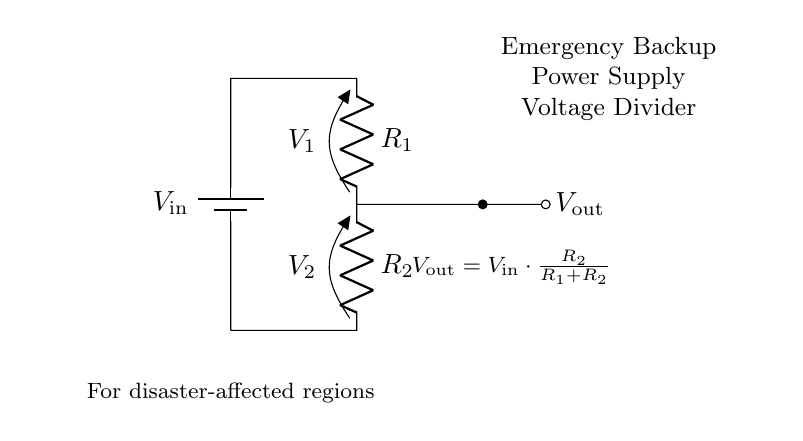What is the input voltage in the circuit? The input voltage is represented as V_in, which is the potential supplied by the battery.
Answer: V_in What does V_out represent? V_out is the output voltage across resistor R2, computed using the voltage divider formula.
Answer: V_out What is the relationship between R1 and R2? R1 and R2 are resistors in series, and their values influence the output voltage V_out. They are connected one after the other in the circuit.
Answer: R1 and R2 are in series What is the formula for V_out? The formula given in the diagram states that V_out is equal to V_in multiplied by the ratio of R2 to the total resistance (R1 + R2).
Answer: V_out = V_in * (R2 / (R1 + R2)) If R1 is larger than R2, what happens to V_out? If R1 is larger than R2, according to the voltage divider principle, V_out will be smaller, as more voltage is dropped across R1.
Answer: V_out decreases How does this circuit help in disaster-affected regions? The voltage divider circuit assists by providing a specific lower voltage output for powering devices that require less voltage than the input, useful for efficient power distribution in emergencies.
Answer: Provides lower voltage output What type of circuit is represented here? This circuit is a Voltage Divider, specifically designed to split an input voltage into smaller outputs based on resistor values.
Answer: Voltage Divider 